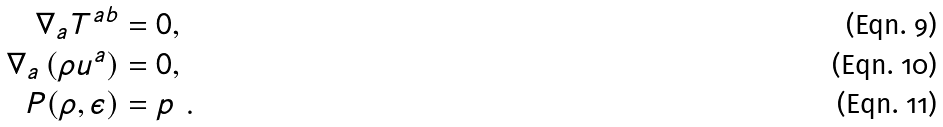<formula> <loc_0><loc_0><loc_500><loc_500>\nabla _ { a } T ^ { a b } & = 0 , \\ \nabla _ { a } \left ( \rho u ^ { a } \right ) & = 0 , \\ P ( \rho , \epsilon ) & = p \ .</formula> 